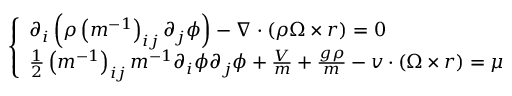<formula> <loc_0><loc_0><loc_500><loc_500>\left \{ \begin{array} { l } { \partial _ { i } \left ( \rho \left ( m ^ { - 1 } \right ) _ { i j } \partial _ { j } \phi \right ) - \nabla \cdot ( \rho \Omega \times r ) = 0 } \\ { \frac { 1 } { 2 } \left ( m ^ { - 1 } \right ) _ { i j } m ^ { - 1 } \partial _ { i } \phi \partial _ { j } \phi + \frac { V } { m } + \frac { g \rho } { m } - v \cdot ( \Omega \times r ) = \mu } \end{array}</formula> 